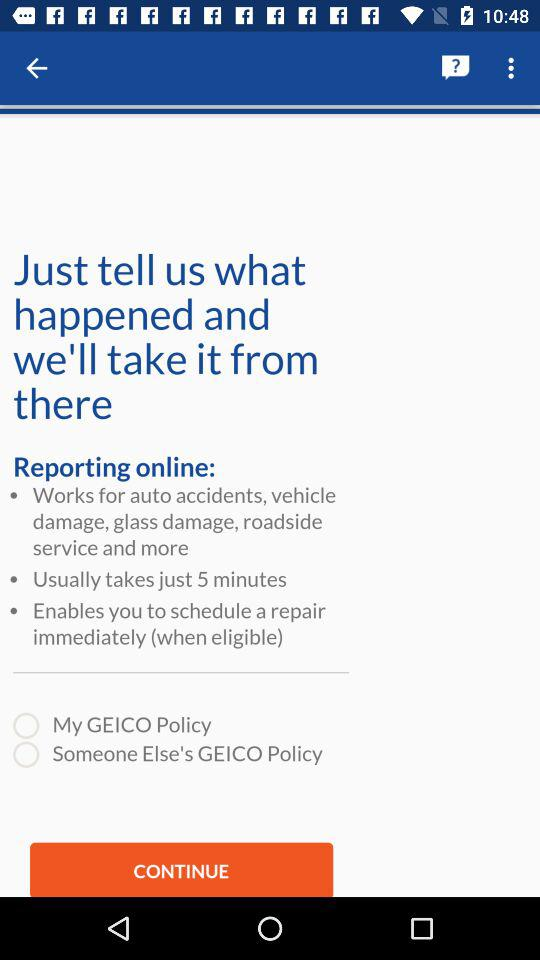What is the status of "My GEICO Policy"? The status is "off". 